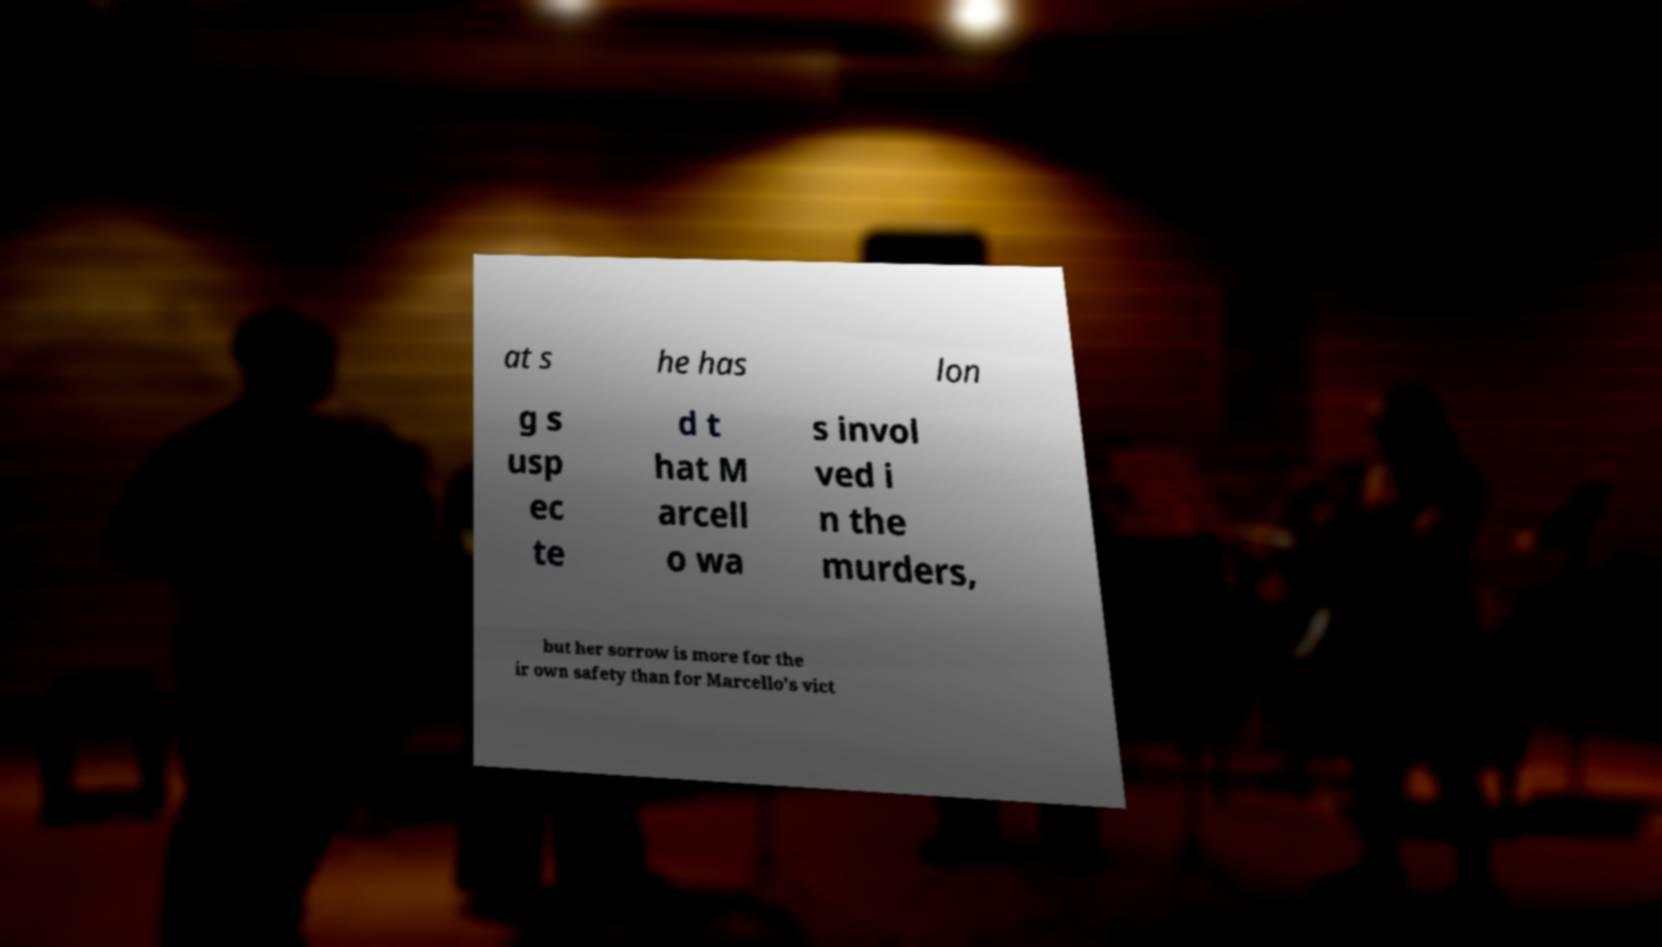I need the written content from this picture converted into text. Can you do that? at s he has lon g s usp ec te d t hat M arcell o wa s invol ved i n the murders, but her sorrow is more for the ir own safety than for Marcello's vict 